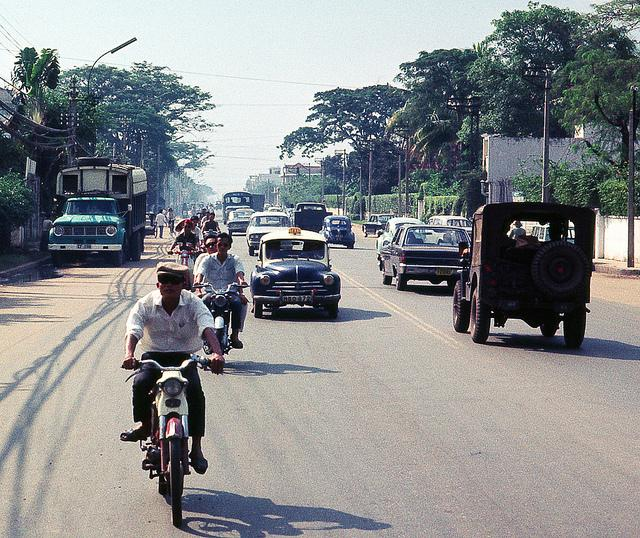What are is the image from?

Choices:
A) forest
B) underground
C) city
D) sky city 